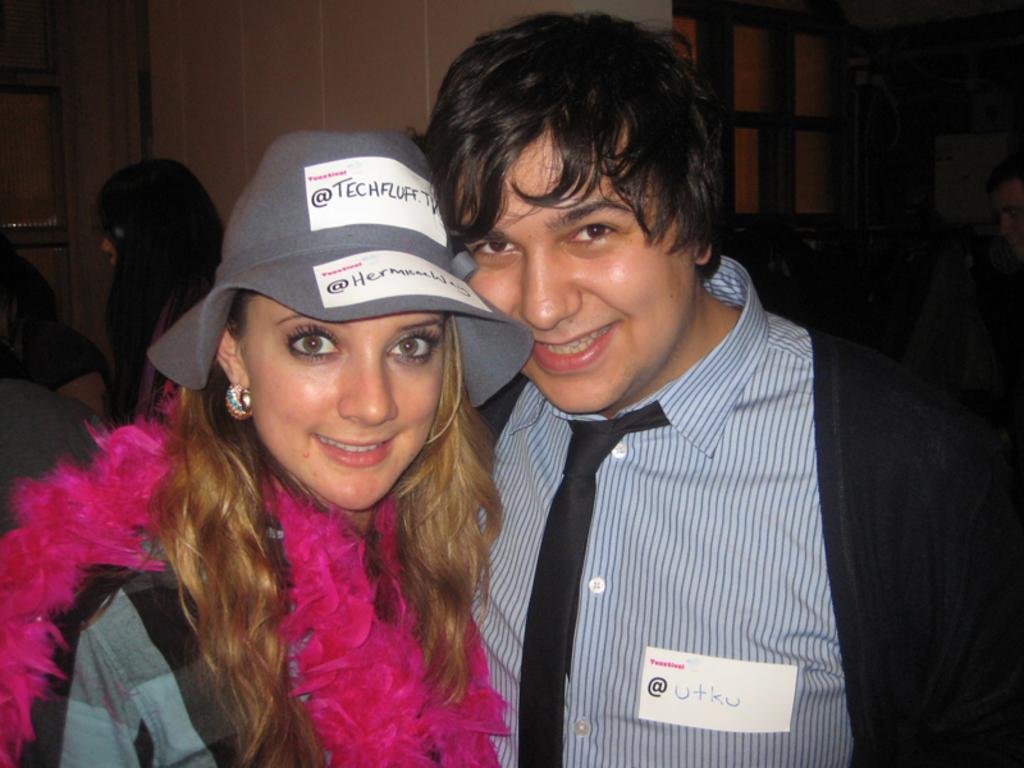Could you give a brief overview of what you see in this image? In this picture we can see a man and a woman standing here, a woman wore a cap, in the background there is a wall, we can see another person on the left side. 